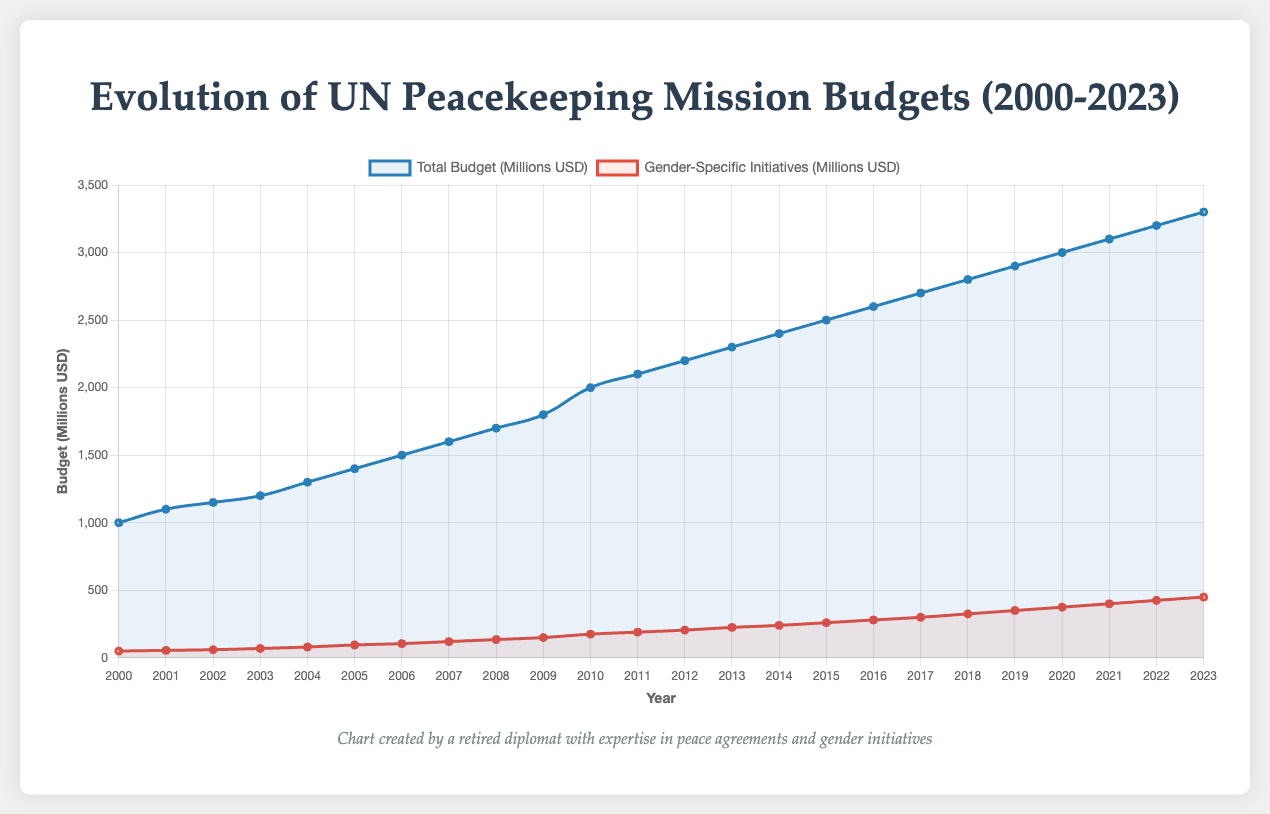What year had the highest total budget for UN peacekeeping missions? Look at the two lines on the plot and identify the year with the highest point on the "Total Budget (Millions USD)" line. The highest point corresponds to the year 2023.
Answer: 2023 How much did the gender-specific initiatives budget increase from 2000 to 2023? Find the values for "Gender-Specific Initiatives (Millions USD)" for the years 2000 and 2023, then subtract the 2000 value from the 2023 value: 450 - 50 = 400.
Answer: 400 million USD Which year saw an increased budget for gender-specific initiatives by more than 20 million dollars compared to the previous year? Search for a year where the increase in "Gender-Specific Initiatives (Millions USD)" exceeds 20 million relative to the previous year. The value increases from 120 million in 2007 to 135 million in 2008, an increase of 15 million. Therefore, the eligible year is 2018 where the increased from 300 million in 2017 to 325 million in 2018 which is 25 million
Answer: 2018 What is the difference in total budget between the years 2010 and 2000? Locate the total budget values for 2010 and 2000 on the "Total Budget (Millions USD)" line and then subtract the 2000 value from the 2010 value: 2000 - 1000 = 1000.
Answer: 1000 million USD By how much did the gender-specific initiatives budget exceed 100 million dollars? Identify the year when "Gender-Specific Initiatives (Millions USD)" first surpasses 100 million. This happens in 2006.
Answer: 2006 In which year did the total budget experience the largest increase from the previous year? To determine the largest increase, look at the year-to-year changes in the "Total Budget (Millions USD)" line. The largest increase can be found between 2009 and 2010, where the budget goes from 1800 to 2000, an increase of 200.
Answer: 2010 What is the average annual budget for gender-specific initiatives from 2000 to 2023? Sum up all the values in the "Gender-Specific Initiatives (Millions USD)" and divide by the number of years. The total sum is: 50 + 55 + 60 + 69 + 80 + 95 + 105 + 120 + 135 + 150 + 175 + 190 + 205 + 225 + 240 + 260 + 280 + 300 + 325 + 350 + 375 + 400 + 425 + 450 = 5264. 5264 / 24 years = 219.33.
Answer: 219.33 million USD When did the gender-specific initiatives budget and the total budget first exceed 300 million and 3000 million respectively? Look for the first year on the "Gender-Specific Initiatives (Millions USD)" line where the value exceeds 300 million and the "Total Budget (Millions USD)" line exceeds 3000 million. For gender-specific initiatives, this occurs in 2017, and for total budget, it occurs in 2020.
Answer: Gender-specific initiatives in 2017, total budget in 2020 Compare the budget increase for gender-specific initiatives between 2015 to 2016 and 2016 to 2017, which year saw a higher increase? Calculate the increase for each period: from 2015 to 2016: 280 - 260 = 20 million, and from 2016 to 2017: 300 - 280 = 20 million. Both periods saw the same increase
Answer: Both years had the same increase (20 million USD) 